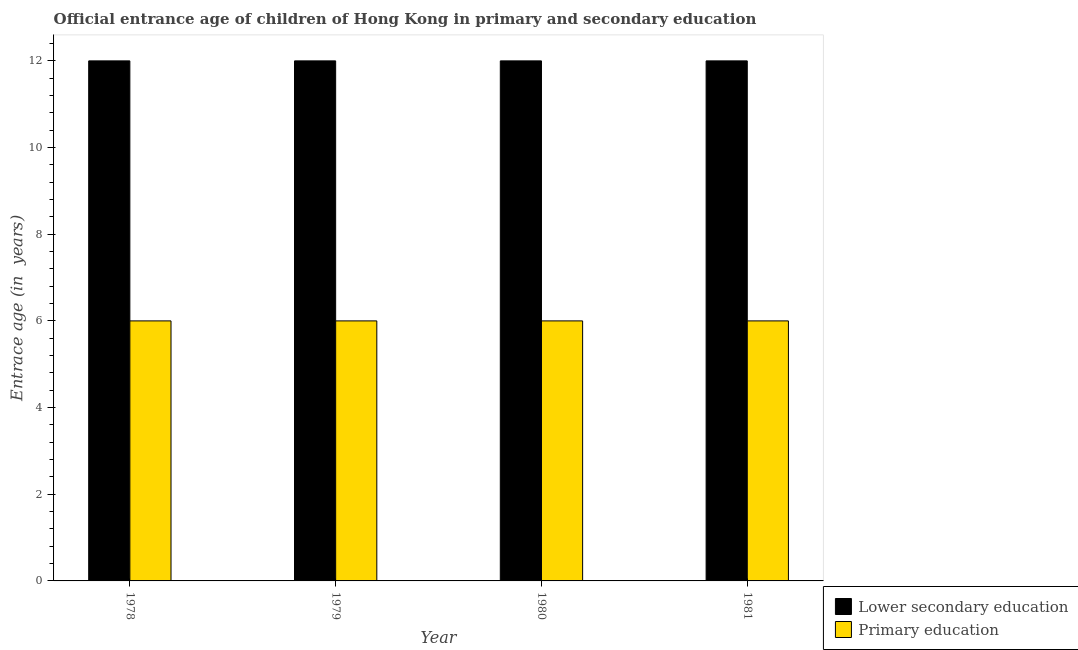Are the number of bars on each tick of the X-axis equal?
Your answer should be very brief. Yes. How many bars are there on the 1st tick from the left?
Provide a succinct answer. 2. How many bars are there on the 3rd tick from the right?
Make the answer very short. 2. What is the label of the 2nd group of bars from the left?
Give a very brief answer. 1979. In how many cases, is the number of bars for a given year not equal to the number of legend labels?
Your answer should be compact. 0. What is the entrance age of children in lower secondary education in 1978?
Your answer should be very brief. 12. Across all years, what is the maximum entrance age of chiildren in primary education?
Your answer should be compact. 6. Across all years, what is the minimum entrance age of children in lower secondary education?
Your answer should be very brief. 12. In which year was the entrance age of chiildren in primary education maximum?
Ensure brevity in your answer.  1978. In which year was the entrance age of chiildren in primary education minimum?
Provide a succinct answer. 1978. What is the total entrance age of children in lower secondary education in the graph?
Give a very brief answer. 48. What is the difference between the entrance age of chiildren in primary education in 1978 and that in 1981?
Ensure brevity in your answer.  0. What is the average entrance age of children in lower secondary education per year?
Your response must be concise. 12. In how many years, is the entrance age of children in lower secondary education greater than 8 years?
Give a very brief answer. 4. Is the entrance age of children in lower secondary education in 1978 less than that in 1979?
Provide a short and direct response. No. What is the difference between the highest and the second highest entrance age of children in lower secondary education?
Provide a short and direct response. 0. What is the difference between the highest and the lowest entrance age of chiildren in primary education?
Offer a very short reply. 0. In how many years, is the entrance age of children in lower secondary education greater than the average entrance age of children in lower secondary education taken over all years?
Provide a short and direct response. 0. What does the 2nd bar from the left in 1980 represents?
Provide a succinct answer. Primary education. What does the 2nd bar from the right in 1981 represents?
Provide a short and direct response. Lower secondary education. How many years are there in the graph?
Offer a terse response. 4. What is the difference between two consecutive major ticks on the Y-axis?
Your answer should be very brief. 2. How many legend labels are there?
Offer a terse response. 2. What is the title of the graph?
Give a very brief answer. Official entrance age of children of Hong Kong in primary and secondary education. What is the label or title of the X-axis?
Give a very brief answer. Year. What is the label or title of the Y-axis?
Offer a terse response. Entrace age (in  years). What is the Entrace age (in  years) of Lower secondary education in 1980?
Your response must be concise. 12. What is the Entrace age (in  years) of Lower secondary education in 1981?
Offer a very short reply. 12. What is the Entrace age (in  years) in Primary education in 1981?
Provide a short and direct response. 6. Across all years, what is the maximum Entrace age (in  years) of Lower secondary education?
Keep it short and to the point. 12. Across all years, what is the maximum Entrace age (in  years) in Primary education?
Offer a terse response. 6. Across all years, what is the minimum Entrace age (in  years) in Lower secondary education?
Offer a very short reply. 12. What is the total Entrace age (in  years) of Lower secondary education in the graph?
Offer a terse response. 48. What is the total Entrace age (in  years) of Primary education in the graph?
Offer a terse response. 24. What is the difference between the Entrace age (in  years) in Lower secondary education in 1978 and that in 1979?
Give a very brief answer. 0. What is the difference between the Entrace age (in  years) of Lower secondary education in 1979 and that in 1980?
Your response must be concise. 0. What is the difference between the Entrace age (in  years) of Lower secondary education in 1979 and that in 1981?
Give a very brief answer. 0. What is the difference between the Entrace age (in  years) of Primary education in 1980 and that in 1981?
Your answer should be very brief. 0. What is the difference between the Entrace age (in  years) of Lower secondary education in 1978 and the Entrace age (in  years) of Primary education in 1979?
Keep it short and to the point. 6. What is the difference between the Entrace age (in  years) in Lower secondary education in 1979 and the Entrace age (in  years) in Primary education in 1981?
Keep it short and to the point. 6. What is the difference between the Entrace age (in  years) in Lower secondary education in 1980 and the Entrace age (in  years) in Primary education in 1981?
Your answer should be compact. 6. What is the average Entrace age (in  years) in Lower secondary education per year?
Provide a succinct answer. 12. In the year 1979, what is the difference between the Entrace age (in  years) of Lower secondary education and Entrace age (in  years) of Primary education?
Provide a succinct answer. 6. In the year 1980, what is the difference between the Entrace age (in  years) of Lower secondary education and Entrace age (in  years) of Primary education?
Offer a very short reply. 6. In the year 1981, what is the difference between the Entrace age (in  years) in Lower secondary education and Entrace age (in  years) in Primary education?
Offer a terse response. 6. What is the ratio of the Entrace age (in  years) in Primary education in 1978 to that in 1979?
Offer a terse response. 1. What is the ratio of the Entrace age (in  years) of Lower secondary education in 1978 to that in 1981?
Offer a very short reply. 1. What is the ratio of the Entrace age (in  years) in Primary education in 1978 to that in 1981?
Ensure brevity in your answer.  1. What is the ratio of the Entrace age (in  years) of Lower secondary education in 1979 to that in 1980?
Your answer should be very brief. 1. What is the ratio of the Entrace age (in  years) of Primary education in 1979 to that in 1980?
Ensure brevity in your answer.  1. What is the ratio of the Entrace age (in  years) of Lower secondary education in 1979 to that in 1981?
Offer a terse response. 1. What is the ratio of the Entrace age (in  years) in Primary education in 1980 to that in 1981?
Offer a terse response. 1. 